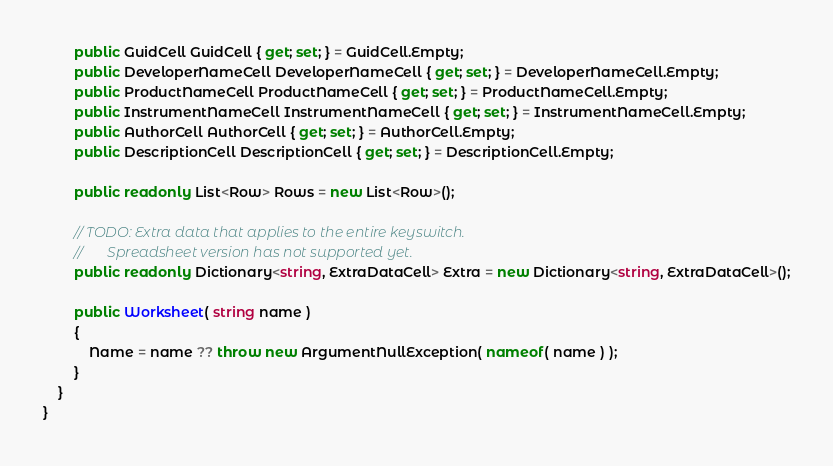Convert code to text. <code><loc_0><loc_0><loc_500><loc_500><_C#_>        public GuidCell GuidCell { get; set; } = GuidCell.Empty;
        public DeveloperNameCell DeveloperNameCell { get; set; } = DeveloperNameCell.Empty;
        public ProductNameCell ProductNameCell { get; set; } = ProductNameCell.Empty;
        public InstrumentNameCell InstrumentNameCell { get; set; } = InstrumentNameCell.Empty;
        public AuthorCell AuthorCell { get; set; } = AuthorCell.Empty;
        public DescriptionCell DescriptionCell { get; set; } = DescriptionCell.Empty;

        public readonly List<Row> Rows = new List<Row>();

        // TODO: Extra data that applies to the entire keyswitch.
        //       Spreadsheet version has not supported yet.
        public readonly Dictionary<string, ExtraDataCell> Extra = new Dictionary<string, ExtraDataCell>();

        public Worksheet( string name )
        {
            Name = name ?? throw new ArgumentNullException( nameof( name ) );
        }
    }
}</code> 